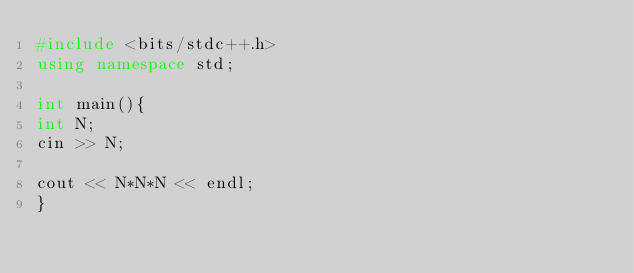Convert code to text. <code><loc_0><loc_0><loc_500><loc_500><_C++_>#include <bits/stdc++.h>
using namespace std;

int main(){
int N;
cin >> N;

cout << N*N*N << endl;
}</code> 